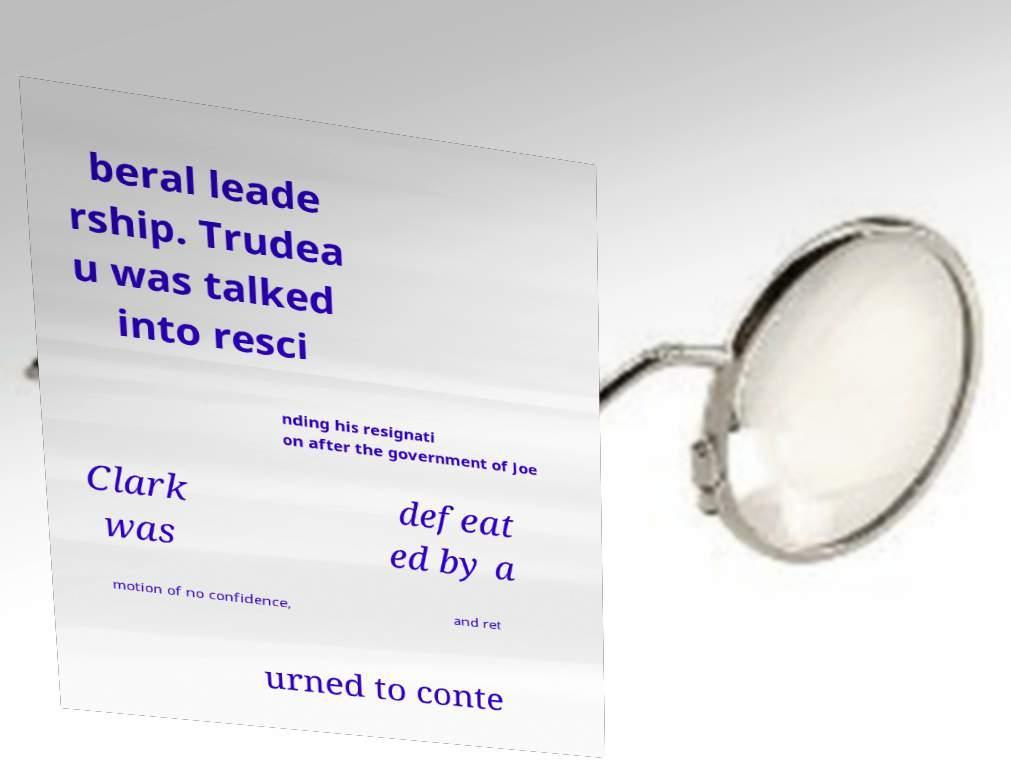What messages or text are displayed in this image? I need them in a readable, typed format. beral leade rship. Trudea u was talked into resci nding his resignati on after the government of Joe Clark was defeat ed by a motion of no confidence, and ret urned to conte 